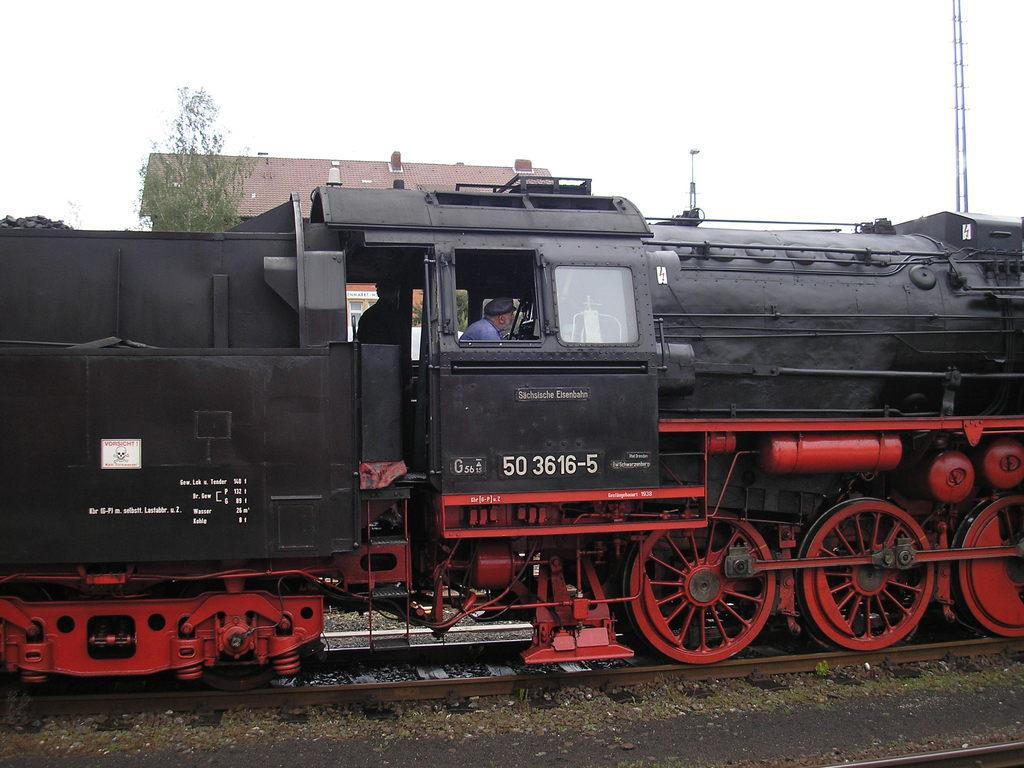Could you give a brief overview of what you see in this image? In this picture we can see a person on the train. This train is on a railway track. We can see a tower, pole, house and a tree in the background. 